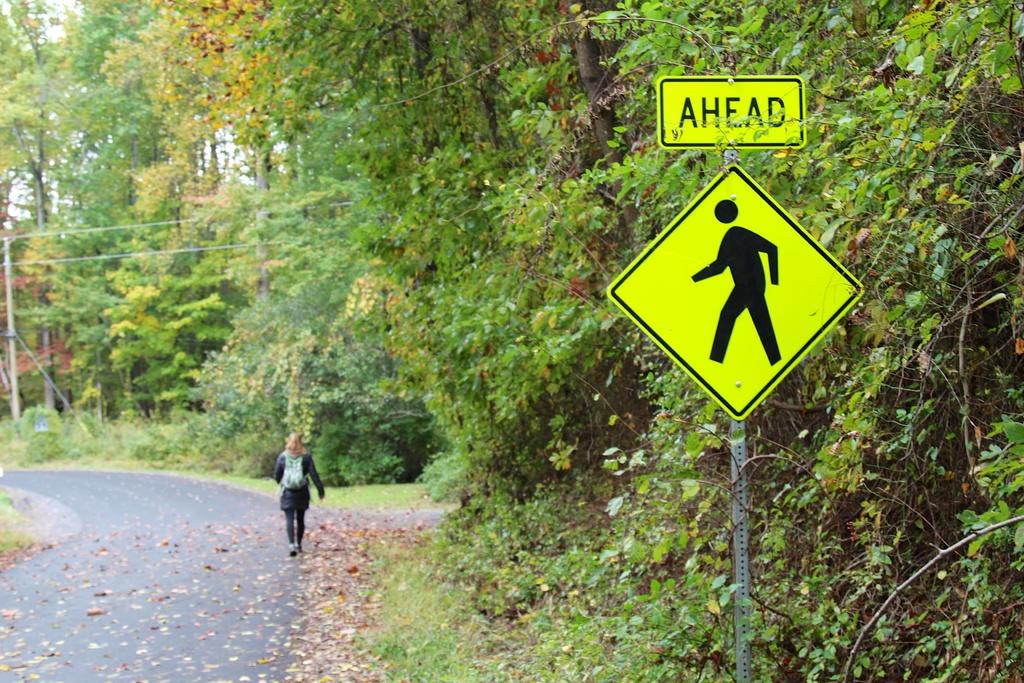What color is the text written in?
Provide a short and direct response. Black. 